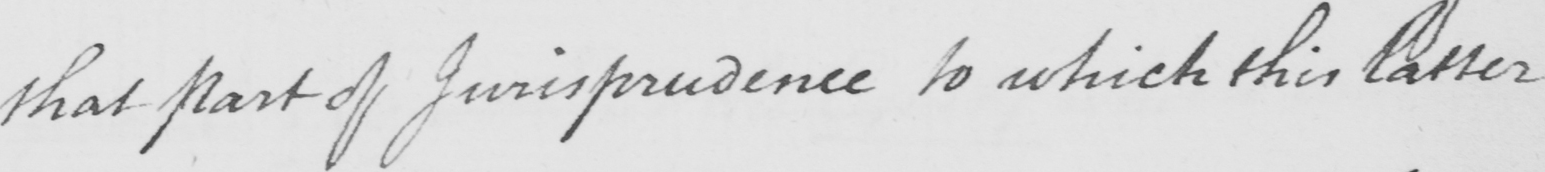Please transcribe the handwritten text in this image. that part of Jurisprudence to which this latter 